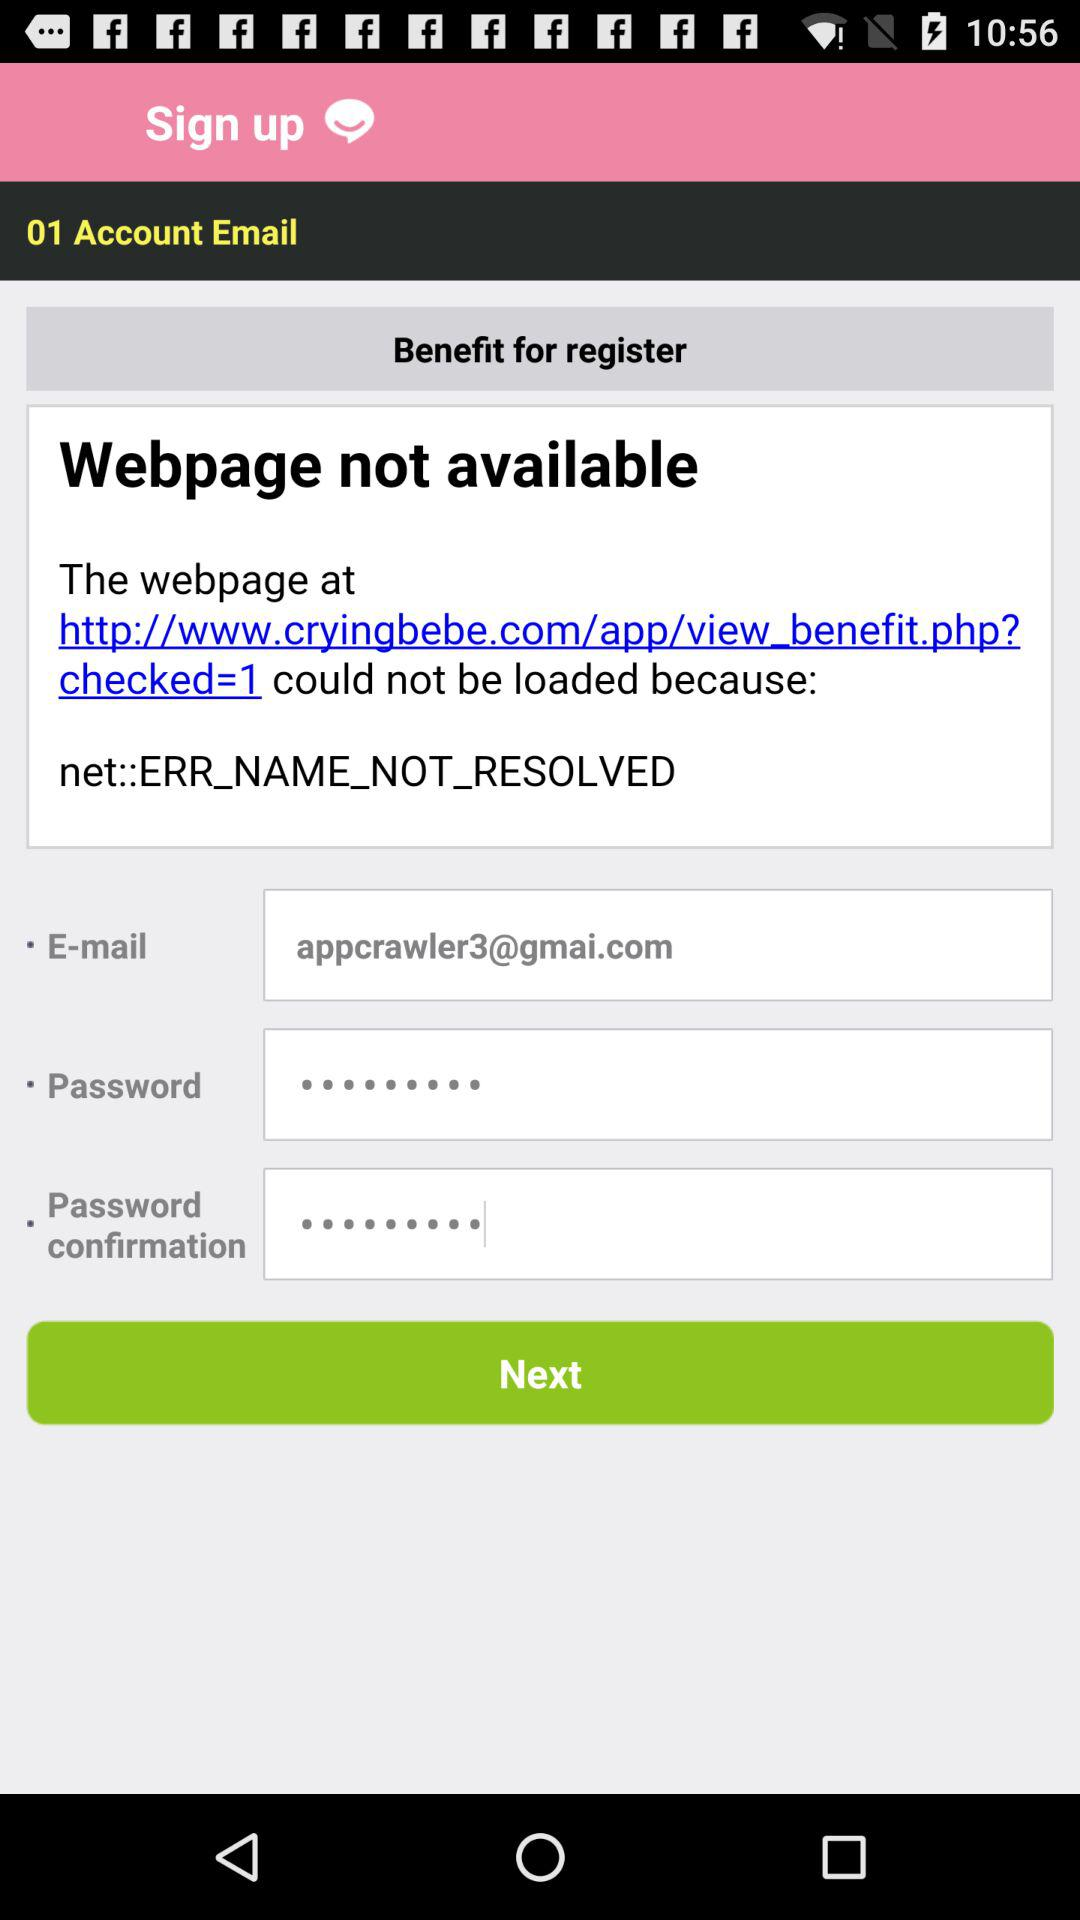How many text inputs have an empty value?
Answer the question using a single word or phrase. 0 